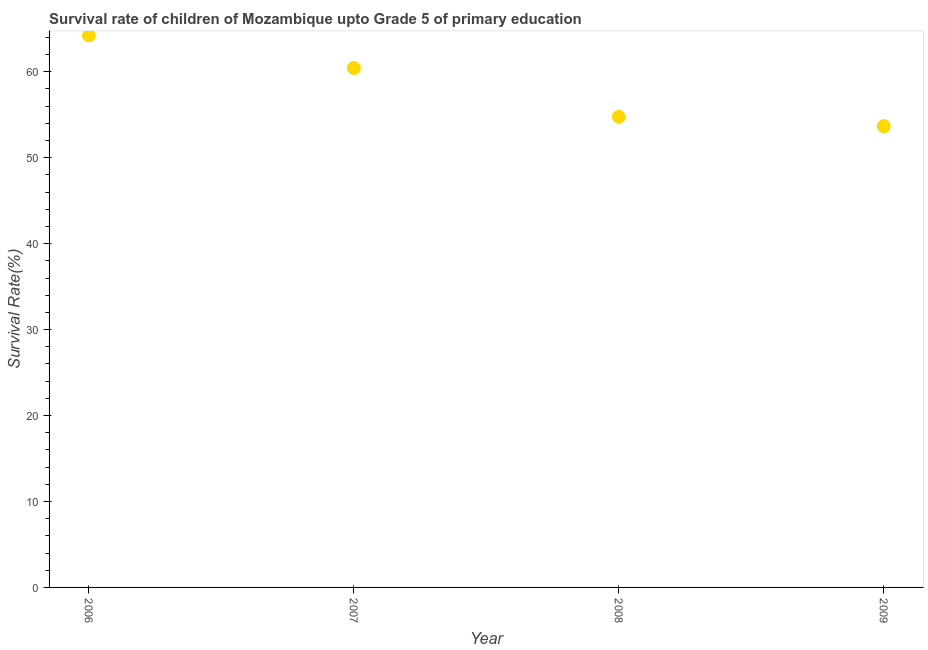What is the survival rate in 2008?
Offer a terse response. 54.76. Across all years, what is the maximum survival rate?
Your answer should be very brief. 64.24. Across all years, what is the minimum survival rate?
Give a very brief answer. 53.67. What is the sum of the survival rate?
Your answer should be compact. 233.11. What is the difference between the survival rate in 2007 and 2008?
Ensure brevity in your answer.  5.68. What is the average survival rate per year?
Your response must be concise. 58.28. What is the median survival rate?
Your answer should be compact. 57.6. Do a majority of the years between 2009 and 2006 (inclusive) have survival rate greater than 34 %?
Offer a terse response. Yes. What is the ratio of the survival rate in 2007 to that in 2008?
Ensure brevity in your answer.  1.1. Is the survival rate in 2006 less than that in 2008?
Offer a very short reply. No. Is the difference between the survival rate in 2006 and 2009 greater than the difference between any two years?
Offer a terse response. Yes. What is the difference between the highest and the second highest survival rate?
Offer a very short reply. 3.8. Is the sum of the survival rate in 2006 and 2007 greater than the maximum survival rate across all years?
Ensure brevity in your answer.  Yes. What is the difference between the highest and the lowest survival rate?
Your response must be concise. 10.57. Does the survival rate monotonically increase over the years?
Provide a succinct answer. No. How many dotlines are there?
Offer a terse response. 1. How many years are there in the graph?
Provide a succinct answer. 4. What is the difference between two consecutive major ticks on the Y-axis?
Ensure brevity in your answer.  10. What is the title of the graph?
Offer a very short reply. Survival rate of children of Mozambique upto Grade 5 of primary education. What is the label or title of the X-axis?
Make the answer very short. Year. What is the label or title of the Y-axis?
Give a very brief answer. Survival Rate(%). What is the Survival Rate(%) in 2006?
Offer a terse response. 64.24. What is the Survival Rate(%) in 2007?
Keep it short and to the point. 60.44. What is the Survival Rate(%) in 2008?
Keep it short and to the point. 54.76. What is the Survival Rate(%) in 2009?
Keep it short and to the point. 53.67. What is the difference between the Survival Rate(%) in 2006 and 2007?
Offer a very short reply. 3.8. What is the difference between the Survival Rate(%) in 2006 and 2008?
Make the answer very short. 9.48. What is the difference between the Survival Rate(%) in 2006 and 2009?
Provide a succinct answer. 10.57. What is the difference between the Survival Rate(%) in 2007 and 2008?
Make the answer very short. 5.68. What is the difference between the Survival Rate(%) in 2007 and 2009?
Your answer should be compact. 6.76. What is the difference between the Survival Rate(%) in 2008 and 2009?
Ensure brevity in your answer.  1.09. What is the ratio of the Survival Rate(%) in 2006 to that in 2007?
Offer a terse response. 1.06. What is the ratio of the Survival Rate(%) in 2006 to that in 2008?
Your answer should be very brief. 1.17. What is the ratio of the Survival Rate(%) in 2006 to that in 2009?
Offer a terse response. 1.2. What is the ratio of the Survival Rate(%) in 2007 to that in 2008?
Offer a very short reply. 1.1. What is the ratio of the Survival Rate(%) in 2007 to that in 2009?
Your answer should be very brief. 1.13. 